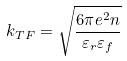<formula> <loc_0><loc_0><loc_500><loc_500>k _ { T F } = \sqrt { \frac { 6 \pi e ^ { 2 } n } { \varepsilon _ { r } \varepsilon _ { f } } }</formula> 